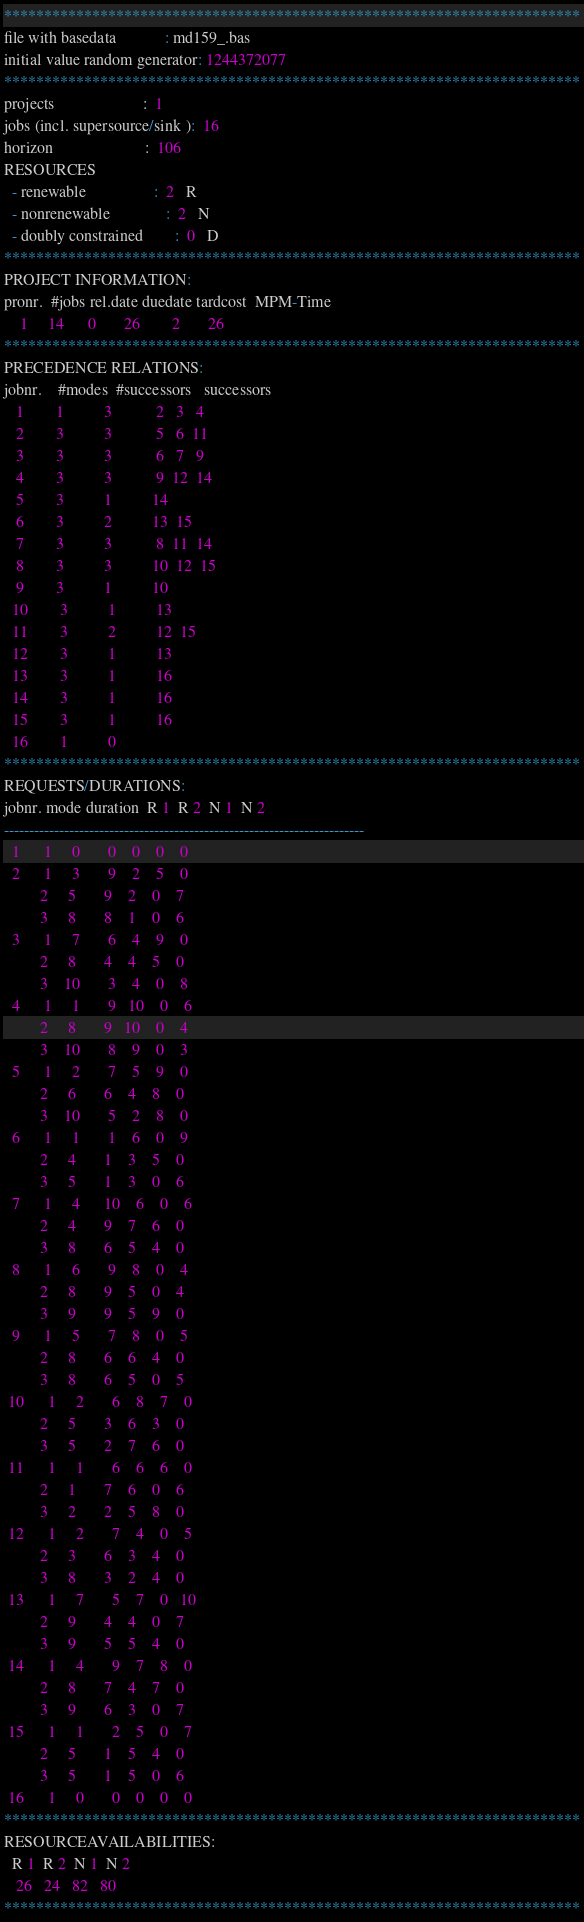<code> <loc_0><loc_0><loc_500><loc_500><_ObjectiveC_>************************************************************************
file with basedata            : md159_.bas
initial value random generator: 1244372077
************************************************************************
projects                      :  1
jobs (incl. supersource/sink ):  16
horizon                       :  106
RESOURCES
  - renewable                 :  2   R
  - nonrenewable              :  2   N
  - doubly constrained        :  0   D
************************************************************************
PROJECT INFORMATION:
pronr.  #jobs rel.date duedate tardcost  MPM-Time
    1     14      0       26        2       26
************************************************************************
PRECEDENCE RELATIONS:
jobnr.    #modes  #successors   successors
   1        1          3           2   3   4
   2        3          3           5   6  11
   3        3          3           6   7   9
   4        3          3           9  12  14
   5        3          1          14
   6        3          2          13  15
   7        3          3           8  11  14
   8        3          3          10  12  15
   9        3          1          10
  10        3          1          13
  11        3          2          12  15
  12        3          1          13
  13        3          1          16
  14        3          1          16
  15        3          1          16
  16        1          0        
************************************************************************
REQUESTS/DURATIONS:
jobnr. mode duration  R 1  R 2  N 1  N 2
------------------------------------------------------------------------
  1      1     0       0    0    0    0
  2      1     3       9    2    5    0
         2     5       9    2    0    7
         3     8       8    1    0    6
  3      1     7       6    4    9    0
         2     8       4    4    5    0
         3    10       3    4    0    8
  4      1     1       9   10    0    6
         2     8       9   10    0    4
         3    10       8    9    0    3
  5      1     2       7    5    9    0
         2     6       6    4    8    0
         3    10       5    2    8    0
  6      1     1       1    6    0    9
         2     4       1    3    5    0
         3     5       1    3    0    6
  7      1     4      10    6    0    6
         2     4       9    7    6    0
         3     8       6    5    4    0
  8      1     6       9    8    0    4
         2     8       9    5    0    4
         3     9       9    5    9    0
  9      1     5       7    8    0    5
         2     8       6    6    4    0
         3     8       6    5    0    5
 10      1     2       6    8    7    0
         2     5       3    6    3    0
         3     5       2    7    6    0
 11      1     1       6    6    6    0
         2     1       7    6    0    6
         3     2       2    5    8    0
 12      1     2       7    4    0    5
         2     3       6    3    4    0
         3     8       3    2    4    0
 13      1     7       5    7    0   10
         2     9       4    4    0    7
         3     9       5    5    4    0
 14      1     4       9    7    8    0
         2     8       7    4    7    0
         3     9       6    3    0    7
 15      1     1       2    5    0    7
         2     5       1    5    4    0
         3     5       1    5    0    6
 16      1     0       0    0    0    0
************************************************************************
RESOURCEAVAILABILITIES:
  R 1  R 2  N 1  N 2
   26   24   82   80
************************************************************************
</code> 